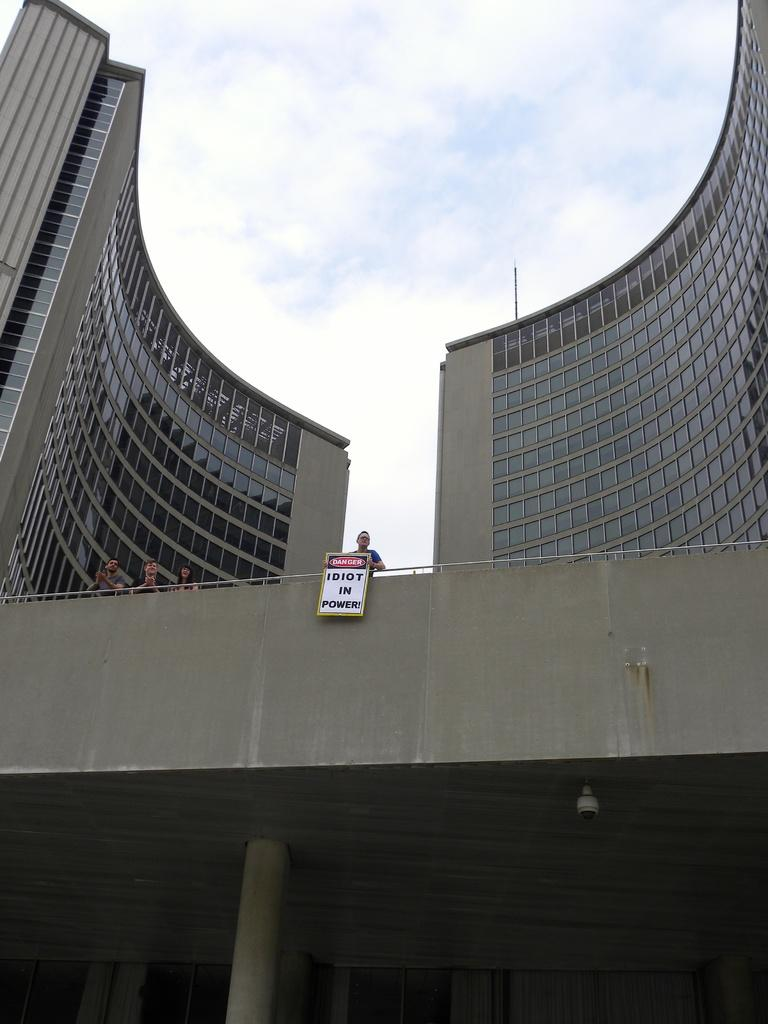How many people are in the image? There are people in the image, but the exact number is not specified. What is one person holding in the image? One person is holding a board in the image. What can be seen in the background of the image? There are buildings, clouds, and the sky visible in the background of the image. What type of polish is being applied to the bike in the image? There is no bike or polish present in the image. Are there any dinosaurs visible in the image? No, there are no dinosaurs present in the image. 